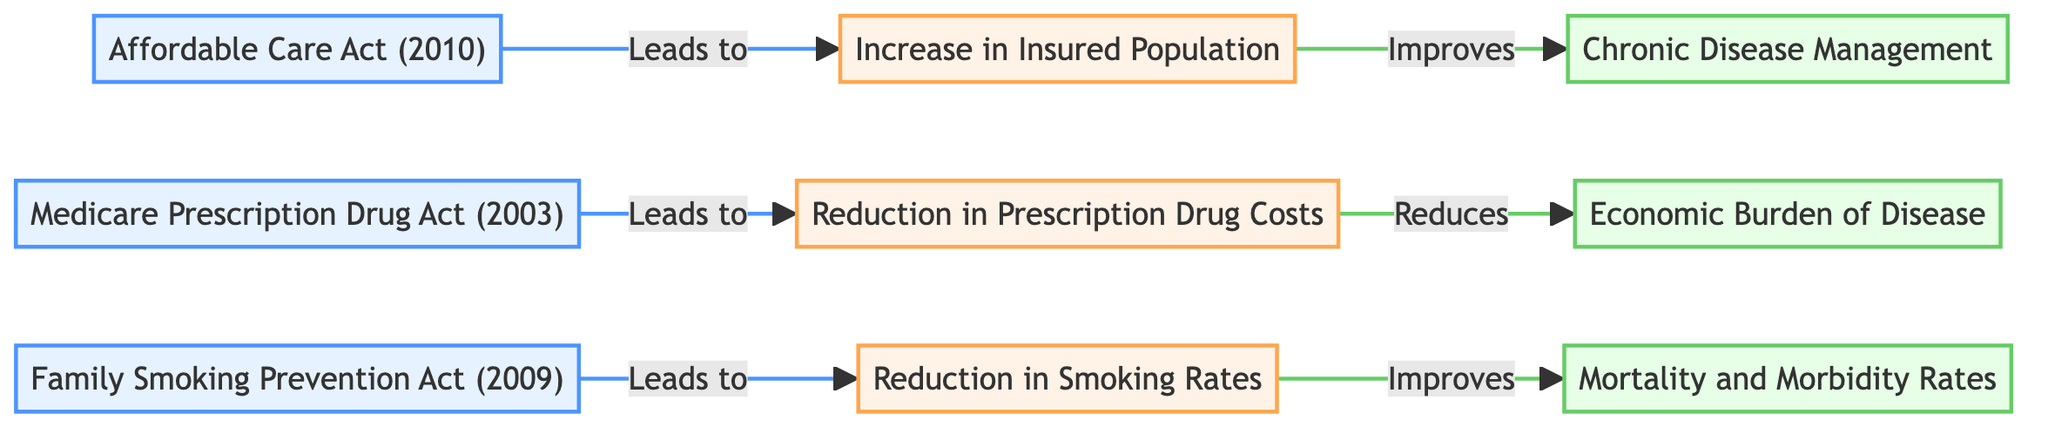What legislation is associated with an increase in the insured population? The diagram indicates that the "Affordable Care Act (2010)" leads to an "Increase in Insured Population." The connection is direct from the legislation node to the health outcome node.
Answer: Affordable Care Act (2010) Which health outcome is linked to the "Medicare Prescription Drug Act (2003)"? The diagram shows that the "Medicare Prescription Drug Act (2003)" directly leads to a "Reduction in Prescription Drug Costs." This is a simple relationship shown by the arrow from the legislation to the health outcome.
Answer: Reduction in Prescription Drug Costs How many health outcomes are represented in the diagram? Counting the health outcomes in the diagram, there are three nodes labeled as health outcomes: "Increase in Insured Population," "Reduction in Prescription Drug Costs," and "Reduction in Smoking Rates." Therefore, the total is three.
Answer: 3 What public health metric improves as a result of the "Family Smoking Prevention Act (2009)"? The diagram illustrates that the "Family Smoking Prevention Act (2009)" leads to a "Reduction in Smoking Rates," and this health outcome subsequently improves "Mortality and Morbidity Rates." Tracing the flow shows this direct relationship.
Answer: Mortality and Morbidity Rates Which policy leads to a reduction in the economic burden of disease? The diagram indicates that the "Medicare Prescription Drug Act (2003)" leads to a "Reduction in Prescription Drug Costs," which helps in reducing the "Economic Burden of Disease." The flow combines two relationships to form the conclusion.
Answer: Medicare Prescription Drug Act (2003) 